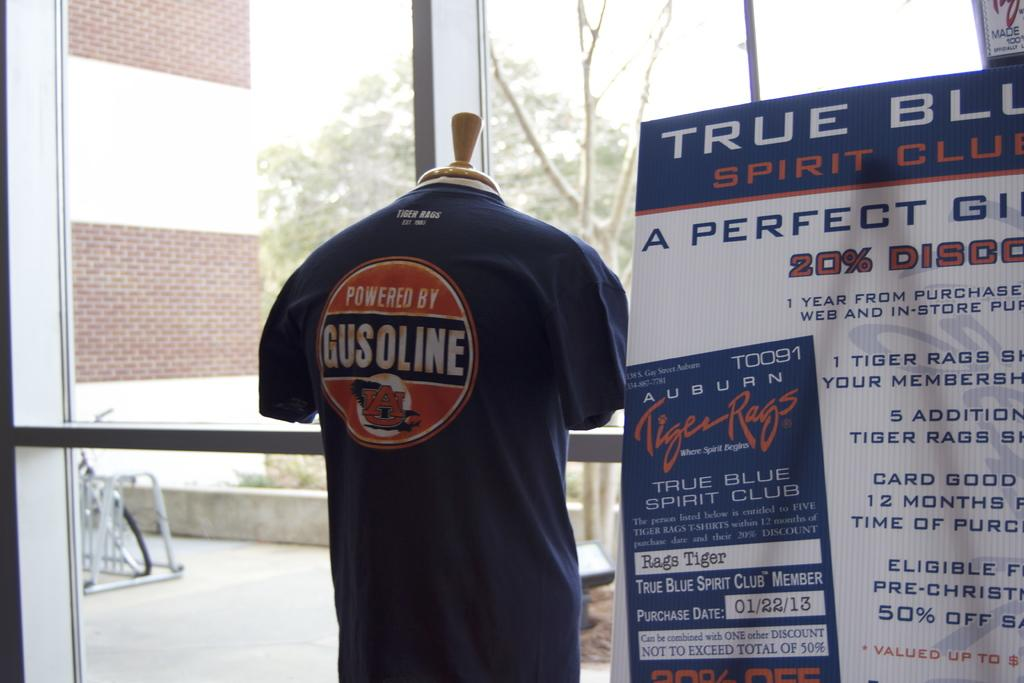<image>
Render a clear and concise summary of the photo. A t-shirt with Gusoline is in a window display. 